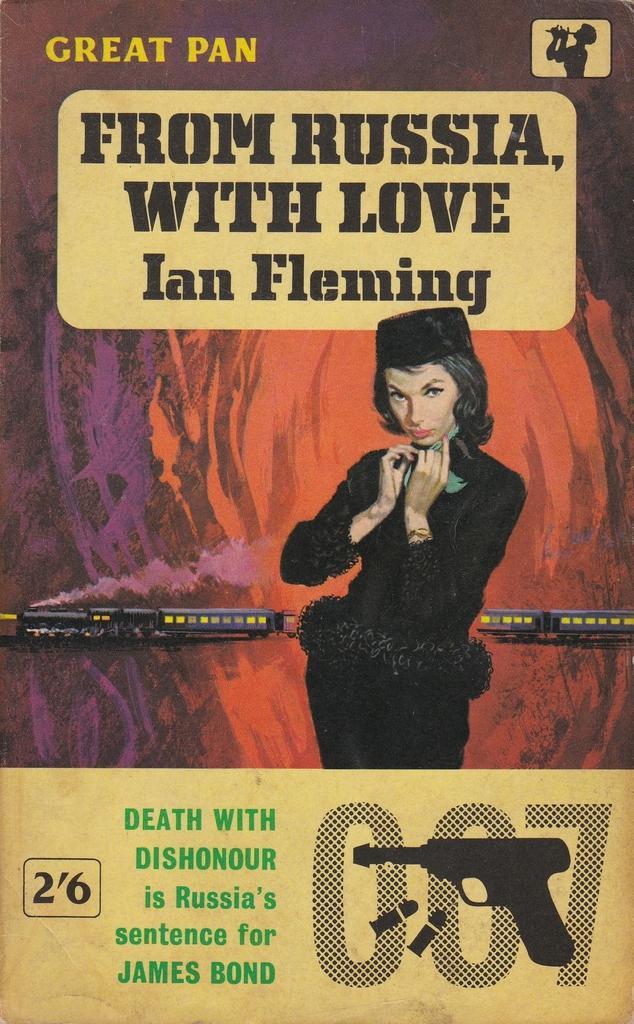How would you summarize this image in a sentence or two? This image consists of a poster in which there is a woman wearing a black dress. And we can see a train in the image. And there is a text. 